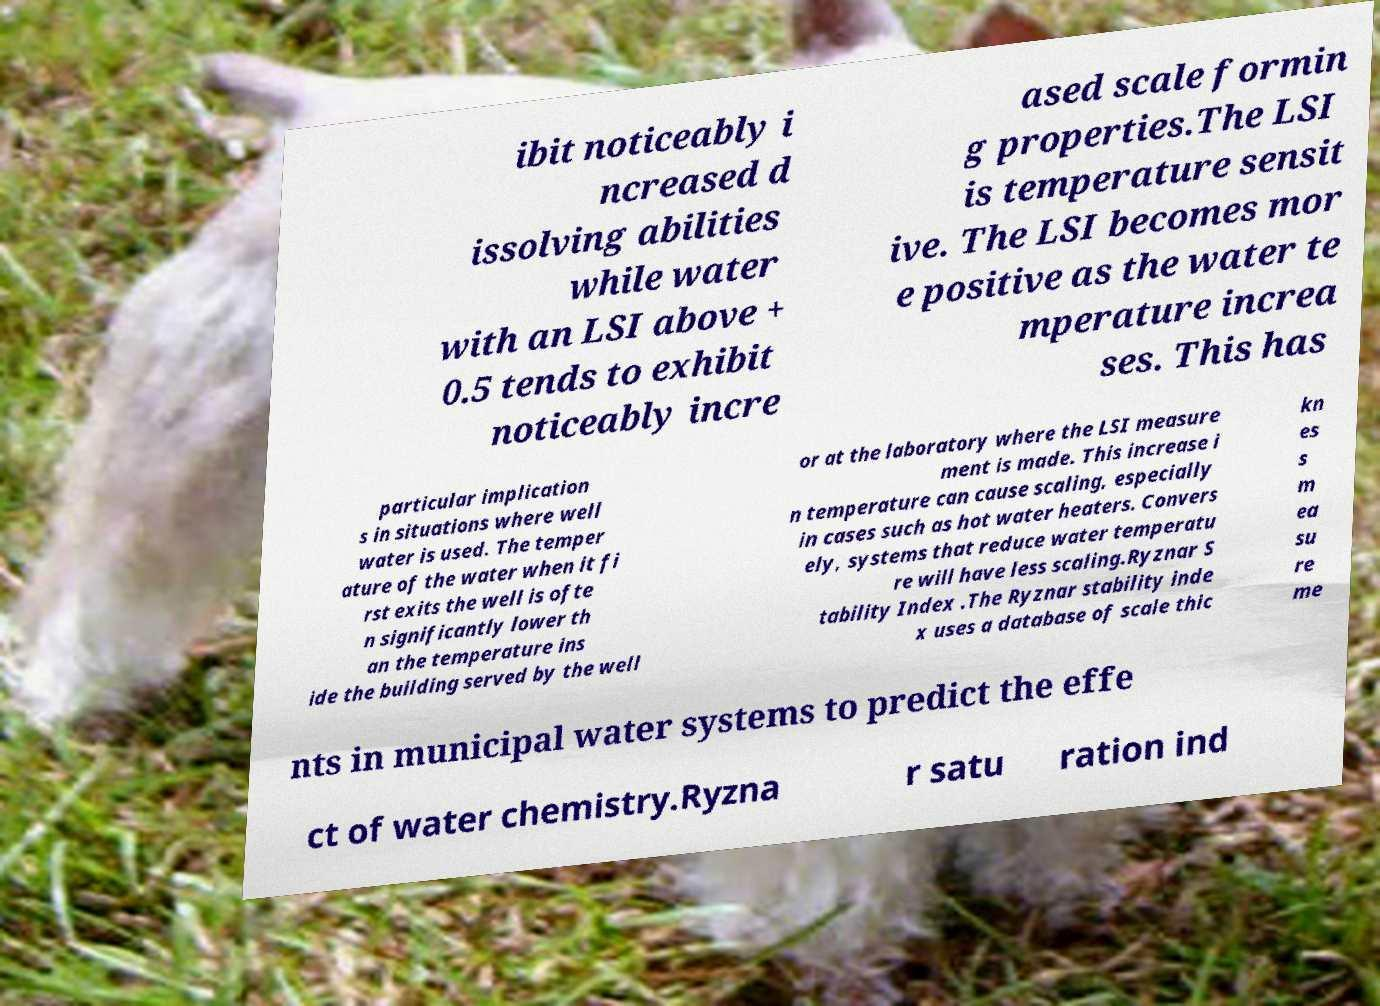I need the written content from this picture converted into text. Can you do that? ibit noticeably i ncreased d issolving abilities while water with an LSI above + 0.5 tends to exhibit noticeably incre ased scale formin g properties.The LSI is temperature sensit ive. The LSI becomes mor e positive as the water te mperature increa ses. This has particular implication s in situations where well water is used. The temper ature of the water when it fi rst exits the well is ofte n significantly lower th an the temperature ins ide the building served by the well or at the laboratory where the LSI measure ment is made. This increase i n temperature can cause scaling, especially in cases such as hot water heaters. Convers ely, systems that reduce water temperatu re will have less scaling.Ryznar S tability Index .The Ryznar stability inde x uses a database of scale thic kn es s m ea su re me nts in municipal water systems to predict the effe ct of water chemistry.Ryzna r satu ration ind 